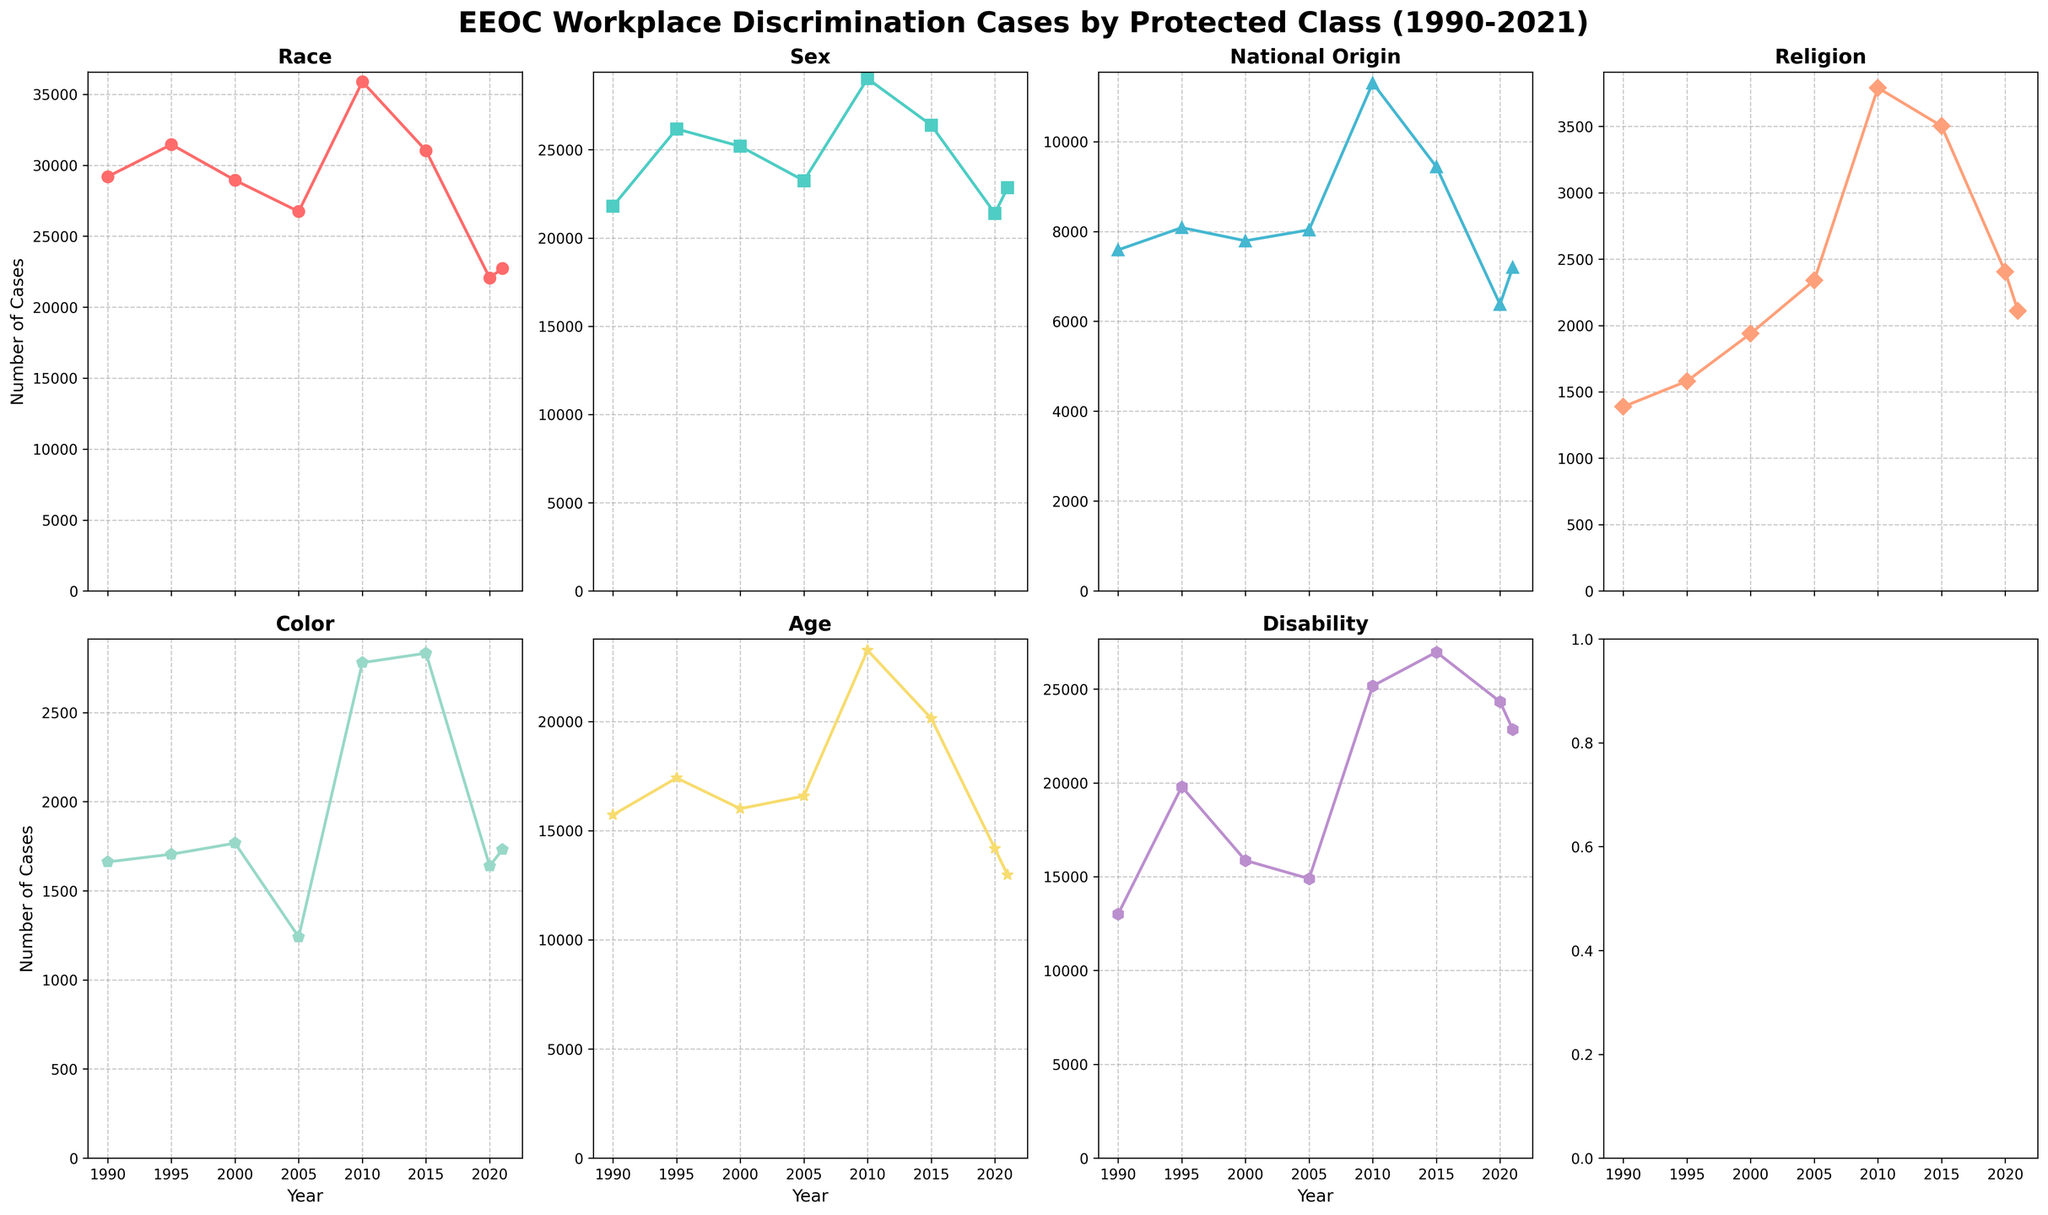Which protected class had the highest number of discrimination cases filed in the year 2010? In the plot for 2010, the line representing Race is the highest. By checking the value for year 2010 in the Race plot, we see it is 35890 cases.
Answer: Race In 2021, did Age-based discrimination cases increase or decrease compared to 2020? The plot for Age in 2021 shows a noticeable drop from the previous year. The value in 2020 is 14183, and in 2021 it is 12965, so it decreased.
Answer: Decrease Which protected class had the largest numerical increase in discrimination cases from 1990 to 2010? Looking at the plots for each category, we calculate the difference for each class by subtracting the 1990 value from the 2010 value. Race increased by 35890 - 29199 = 6691, while disability had the highest increase of 25165 - 13006 = 12159.
Answer: Disability In which year did the National Origin category experience its highest number of cases? By examining the line chart for National Origin, we see that the highest peak occurs in the year 2010 with a value of 11304.
Answer: 2010 Between the years 2005 and 2010, which protected class showed the greatest percentage increase in discrimination cases? For each class, calculate the percentage increase from 2005 to 2010. For example, Race: ((35890-26740)/26740) * 100 = 34.2%. By calculating for each class, Disability shows the greatest percentage increase: ((25165-14893)/14893)*100 ≈ 69%.
Answer: Disability How many protected classes showed a decrease in the number of cases from 2015 to 2020? By inspecting the plots from 2015 to 2020, we see Race, Sex, National Origin, Religion, Color, and Age all show a decrease. There are 6 classes with decreases.
Answer: 6 Did the number of cases for Color-based discrimination ever surpass 3000 in any year? By analyzing the values on the plot for Color, it is clear that the maximum observed value does not reach or surpass 3000.
Answer: No Which protected class experienced a continuous increase in case numbers between 1990 and 2015? Reviewing the plots for each class, we see that Disability consistently increases over this period without any year showing a decrease.
Answer: Disability 